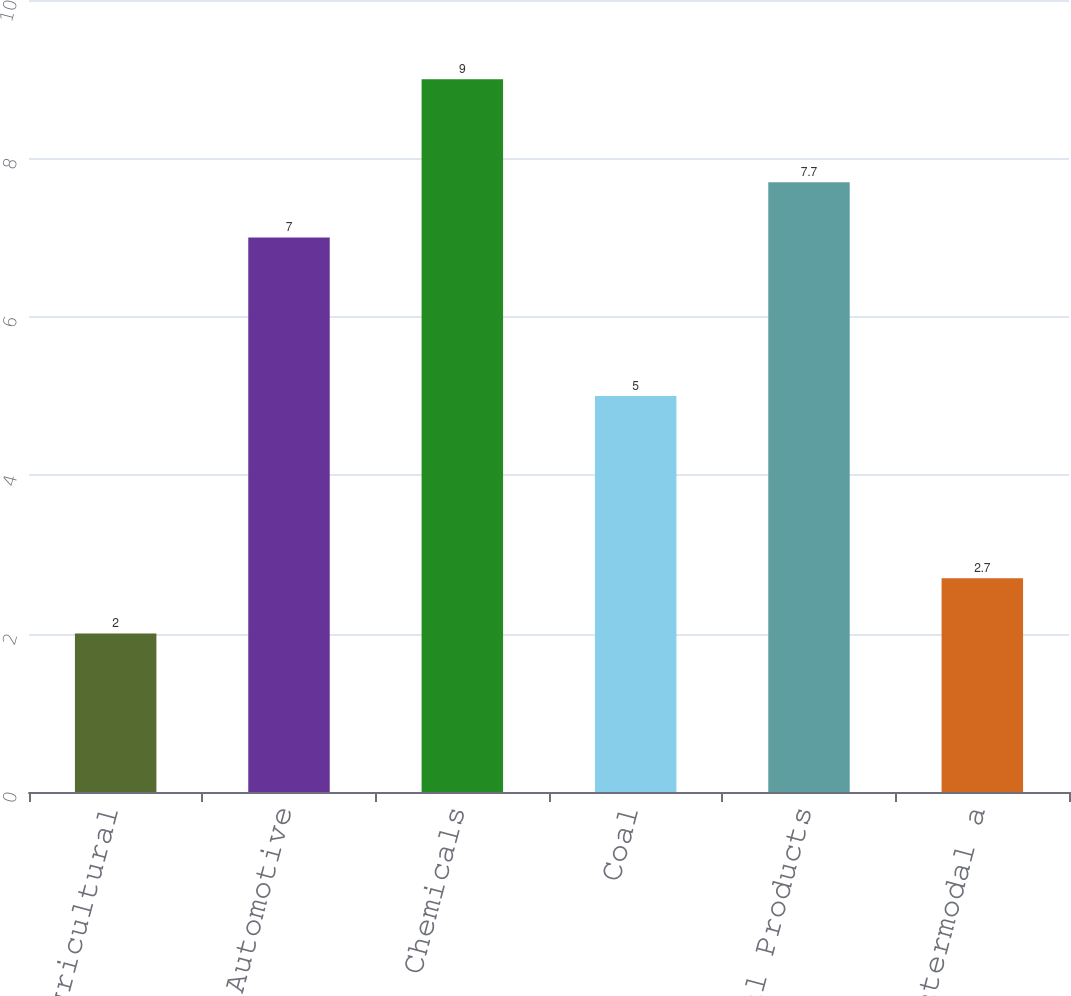<chart> <loc_0><loc_0><loc_500><loc_500><bar_chart><fcel>Agricultural<fcel>Automotive<fcel>Chemicals<fcel>Coal<fcel>Industrial Products<fcel>Intermodal a<nl><fcel>2<fcel>7<fcel>9<fcel>5<fcel>7.7<fcel>2.7<nl></chart> 